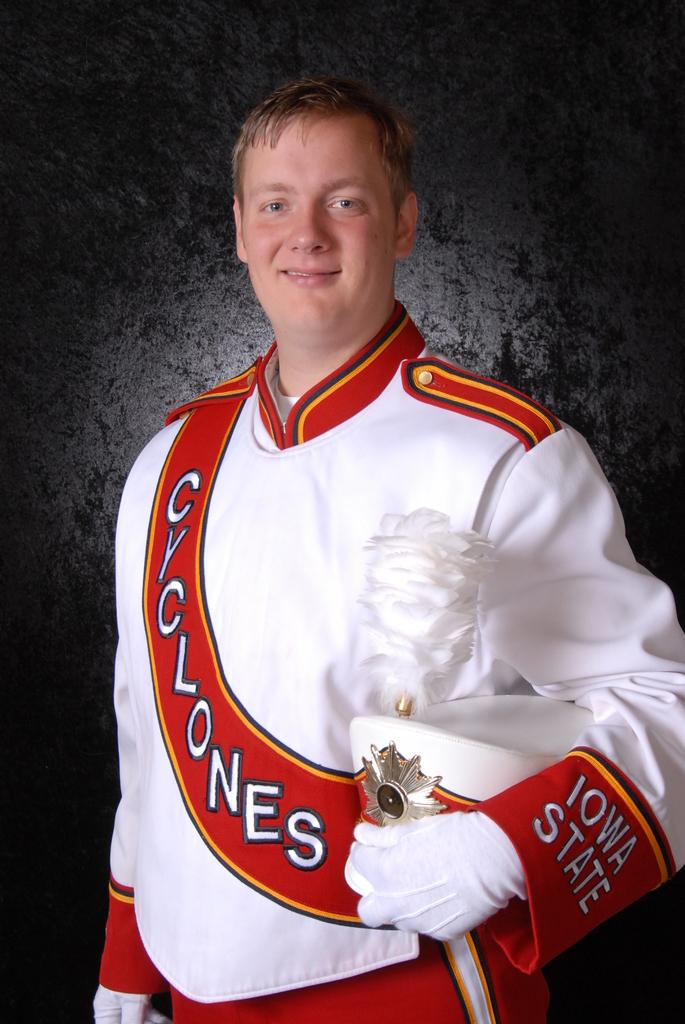Who is present in the image? There is a person in the image. What is the person doing in the image? The person is standing. What object is the person holding in the image? The person is holding a sword in his hand. What type of secretary can be seen assisting the person in the image? There is no secretary present in the image. What color are the trousers worn by the person in the image? The provided facts do not mention the color of the person's trousers. What is the person using to fill the bucket in the image? There is no bucket present in the image. 